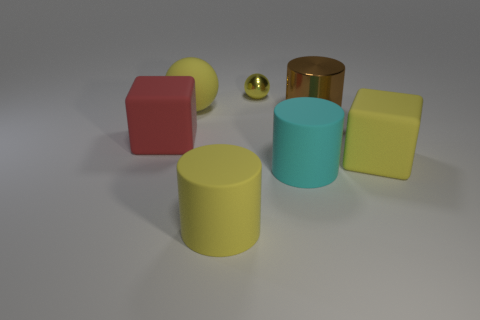Are there any other things that have the same size as the metallic sphere?
Give a very brief answer. No. Is there anything else that has the same shape as the tiny shiny object?
Provide a succinct answer. Yes. There is a cyan thing; does it have the same shape as the yellow matte object on the left side of the yellow cylinder?
Offer a terse response. No. There is a yellow matte thing that is the same shape as the red object; what is its size?
Your response must be concise. Large. What number of other things are there of the same material as the big yellow cube
Keep it short and to the point. 4. What material is the yellow block?
Offer a very short reply. Rubber. There is a rubber block on the left side of the metallic ball; is it the same color as the large cylinder that is behind the big red cube?
Make the answer very short. No. Are there more brown shiny cylinders on the right side of the tiny yellow metallic ball than large gray matte cylinders?
Your response must be concise. Yes. How many other things are the same color as the matte sphere?
Make the answer very short. 3. There is a yellow thing to the right of the shiny sphere; is it the same size as the red object?
Offer a very short reply. Yes. 